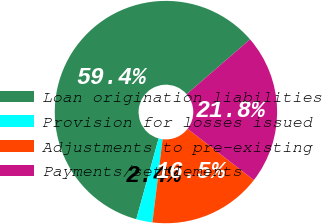Convert chart to OTSL. <chart><loc_0><loc_0><loc_500><loc_500><pie_chart><fcel>Loan origination liabilities<fcel>Provision for losses issued<fcel>Adjustments to pre-existing<fcel>Payments/settlements<nl><fcel>59.36%<fcel>2.36%<fcel>16.46%<fcel>21.82%<nl></chart> 